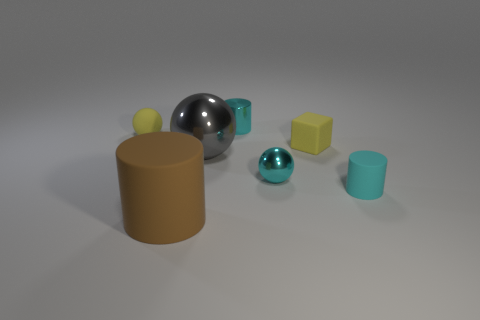Is the number of large brown things to the right of the yellow rubber cube the same as the number of small cyan things that are in front of the yellow sphere?
Give a very brief answer. No. How many other things are the same material as the brown thing?
Provide a succinct answer. 3. Are there an equal number of brown cylinders in front of the big brown matte cylinder and tiny brown metallic spheres?
Provide a short and direct response. Yes. Is the size of the cube the same as the rubber cylinder that is on the right side of the tiny metal cylinder?
Offer a very short reply. Yes. What shape is the yellow object that is to the right of the brown rubber cylinder?
Your answer should be compact. Cube. Are there any small brown cylinders?
Your answer should be compact. No. Does the yellow object left of the big brown object have the same size as the gray thing that is right of the small rubber sphere?
Give a very brief answer. No. The cylinder that is both to the right of the big cylinder and to the left of the cyan rubber thing is made of what material?
Provide a short and direct response. Metal. There is a small cyan shiny cylinder; how many brown cylinders are behind it?
Your answer should be very brief. 0. There is a small cylinder that is made of the same material as the big brown cylinder; what is its color?
Offer a terse response. Cyan. 